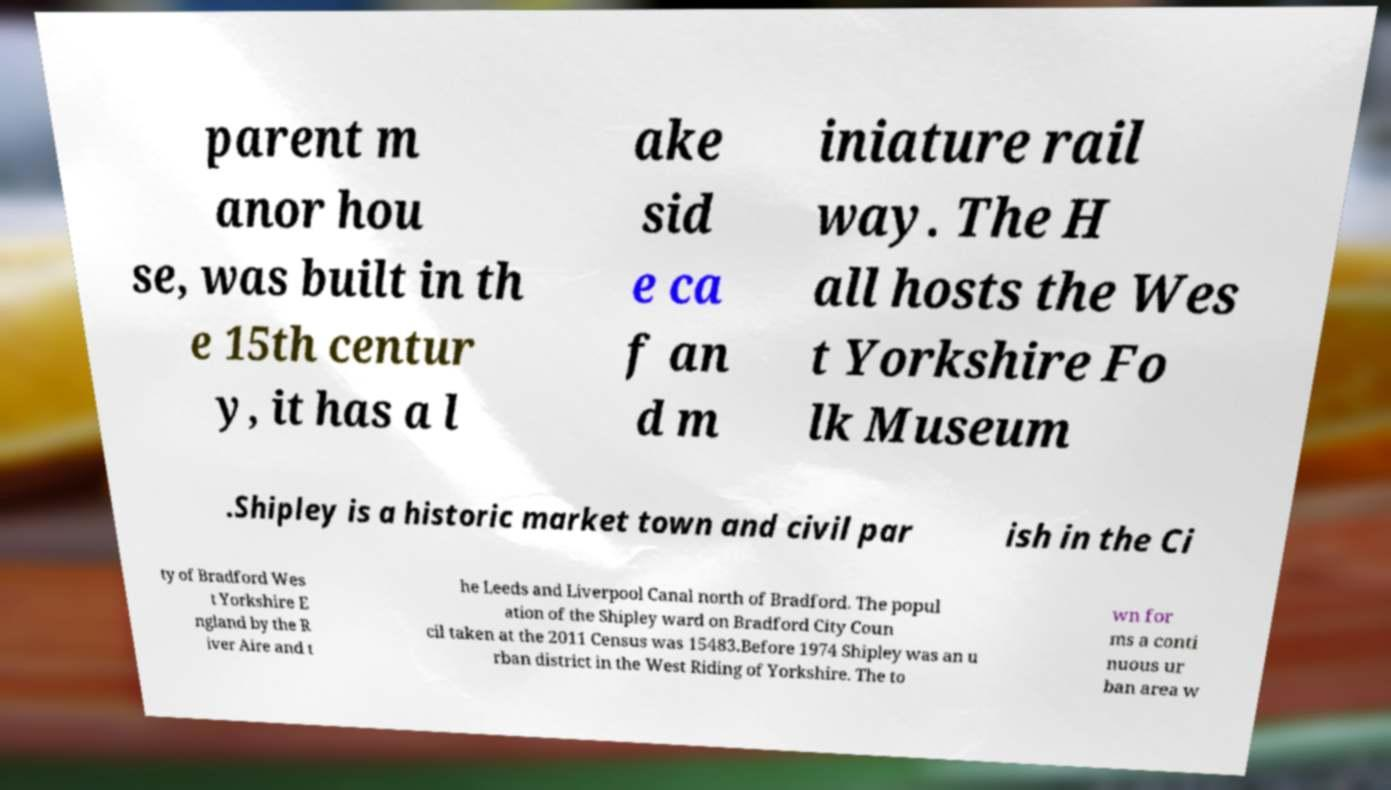There's text embedded in this image that I need extracted. Can you transcribe it verbatim? parent m anor hou se, was built in th e 15th centur y, it has a l ake sid e ca f an d m iniature rail way. The H all hosts the Wes t Yorkshire Fo lk Museum .Shipley is a historic market town and civil par ish in the Ci ty of Bradford Wes t Yorkshire E ngland by the R iver Aire and t he Leeds and Liverpool Canal north of Bradford. The popul ation of the Shipley ward on Bradford City Coun cil taken at the 2011 Census was 15483.Before 1974 Shipley was an u rban district in the West Riding of Yorkshire. The to wn for ms a conti nuous ur ban area w 